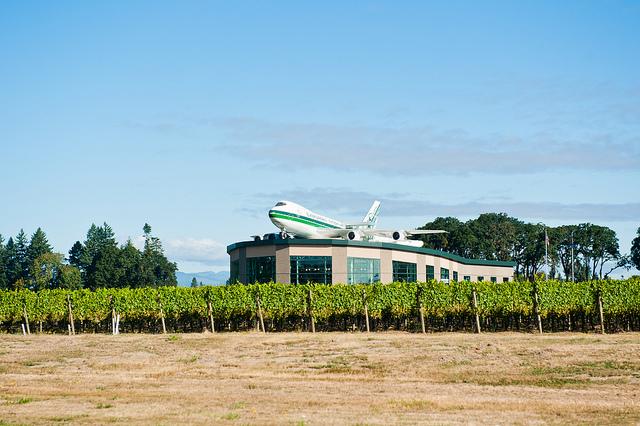Is this airplane ready for takeoff?
Write a very short answer. No. How many buildings are in the picture?
Give a very brief answer. 1. What is on top of the building?
Write a very short answer. Airplane. Is there any dry land in the picture?
Write a very short answer. Yes. Is this a large airport?
Quick response, please. No. Are there planes sitting on a runway?
Be succinct. No. 